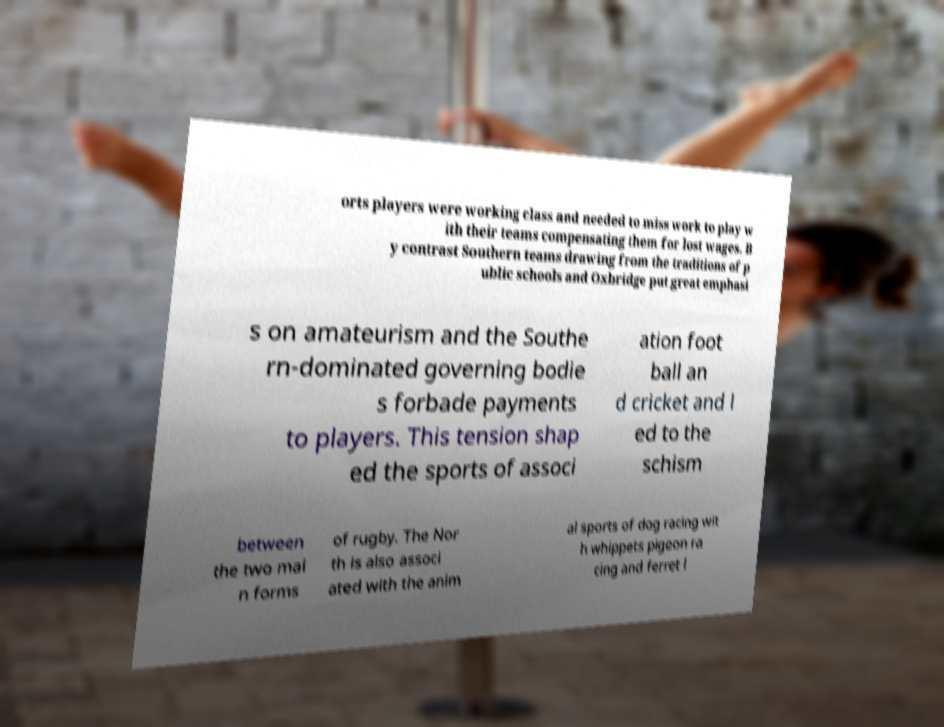I need the written content from this picture converted into text. Can you do that? orts players were working class and needed to miss work to play w ith their teams compensating them for lost wages. B y contrast Southern teams drawing from the traditions of p ublic schools and Oxbridge put great emphasi s on amateurism and the Southe rn-dominated governing bodie s forbade payments to players. This tension shap ed the sports of associ ation foot ball an d cricket and l ed to the schism between the two mai n forms of rugby. The Nor th is also associ ated with the anim al sports of dog racing wit h whippets pigeon ra cing and ferret l 